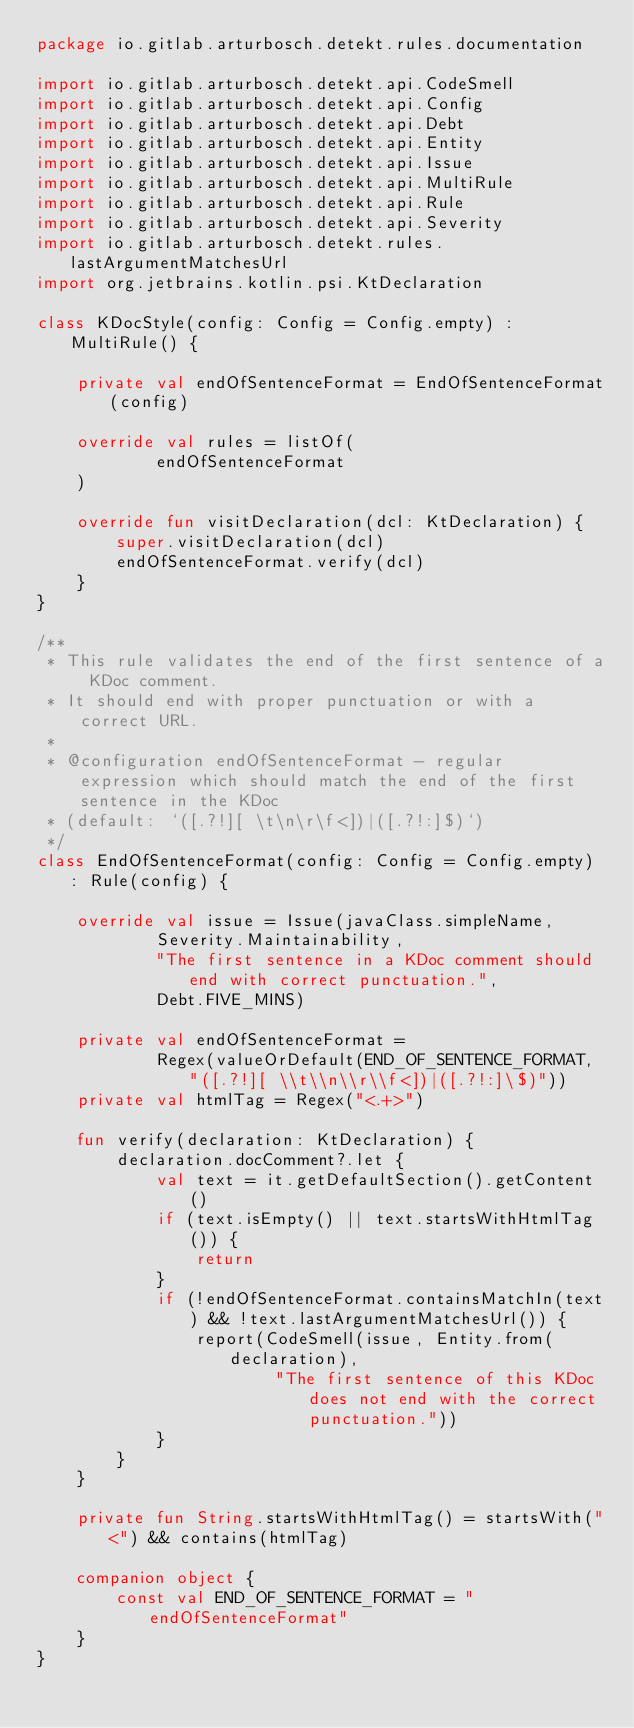Convert code to text. <code><loc_0><loc_0><loc_500><loc_500><_Kotlin_>package io.gitlab.arturbosch.detekt.rules.documentation

import io.gitlab.arturbosch.detekt.api.CodeSmell
import io.gitlab.arturbosch.detekt.api.Config
import io.gitlab.arturbosch.detekt.api.Debt
import io.gitlab.arturbosch.detekt.api.Entity
import io.gitlab.arturbosch.detekt.api.Issue
import io.gitlab.arturbosch.detekt.api.MultiRule
import io.gitlab.arturbosch.detekt.api.Rule
import io.gitlab.arturbosch.detekt.api.Severity
import io.gitlab.arturbosch.detekt.rules.lastArgumentMatchesUrl
import org.jetbrains.kotlin.psi.KtDeclaration

class KDocStyle(config: Config = Config.empty) : MultiRule() {

    private val endOfSentenceFormat = EndOfSentenceFormat(config)

    override val rules = listOf(
            endOfSentenceFormat
    )

    override fun visitDeclaration(dcl: KtDeclaration) {
        super.visitDeclaration(dcl)
        endOfSentenceFormat.verify(dcl)
    }
}

/**
 * This rule validates the end of the first sentence of a KDoc comment.
 * It should end with proper punctuation or with a correct URL.
 *
 * @configuration endOfSentenceFormat - regular expression which should match the end of the first sentence in the KDoc
 * (default: `([.?!][ \t\n\r\f<])|([.?!:]$)`)
 */
class EndOfSentenceFormat(config: Config = Config.empty) : Rule(config) {

    override val issue = Issue(javaClass.simpleName,
            Severity.Maintainability,
            "The first sentence in a KDoc comment should end with correct punctuation.",
            Debt.FIVE_MINS)

    private val endOfSentenceFormat =
            Regex(valueOrDefault(END_OF_SENTENCE_FORMAT, "([.?!][ \\t\\n\\r\\f<])|([.?!:]\$)"))
    private val htmlTag = Regex("<.+>")

    fun verify(declaration: KtDeclaration) {
        declaration.docComment?.let {
            val text = it.getDefaultSection().getContent()
            if (text.isEmpty() || text.startsWithHtmlTag()) {
                return
            }
            if (!endOfSentenceFormat.containsMatchIn(text) && !text.lastArgumentMatchesUrl()) {
                report(CodeSmell(issue, Entity.from(declaration),
                        "The first sentence of this KDoc does not end with the correct punctuation."))
            }
        }
    }

    private fun String.startsWithHtmlTag() = startsWith("<") && contains(htmlTag)

    companion object {
        const val END_OF_SENTENCE_FORMAT = "endOfSentenceFormat"
    }
}
</code> 